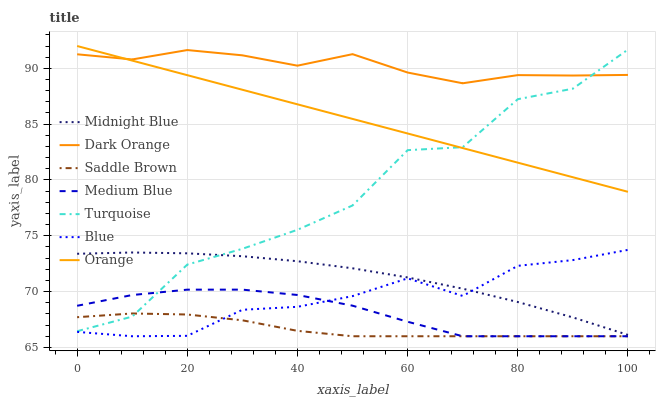Does Turquoise have the minimum area under the curve?
Answer yes or no. No. Does Turquoise have the maximum area under the curve?
Answer yes or no. No. Is Dark Orange the smoothest?
Answer yes or no. No. Is Dark Orange the roughest?
Answer yes or no. No. Does Turquoise have the lowest value?
Answer yes or no. No. Does Dark Orange have the highest value?
Answer yes or no. No. Is Saddle Brown less than Orange?
Answer yes or no. Yes. Is Dark Orange greater than Midnight Blue?
Answer yes or no. Yes. Does Saddle Brown intersect Orange?
Answer yes or no. No. 